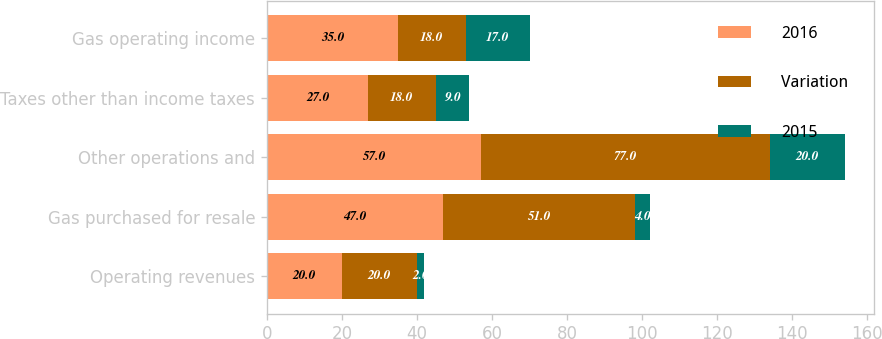Convert chart. <chart><loc_0><loc_0><loc_500><loc_500><stacked_bar_chart><ecel><fcel>Operating revenues<fcel>Gas purchased for resale<fcel>Other operations and<fcel>Taxes other than income taxes<fcel>Gas operating income<nl><fcel>2016<fcel>20<fcel>47<fcel>57<fcel>27<fcel>35<nl><fcel>Variation<fcel>20<fcel>51<fcel>77<fcel>18<fcel>18<nl><fcel>2015<fcel>2<fcel>4<fcel>20<fcel>9<fcel>17<nl></chart> 